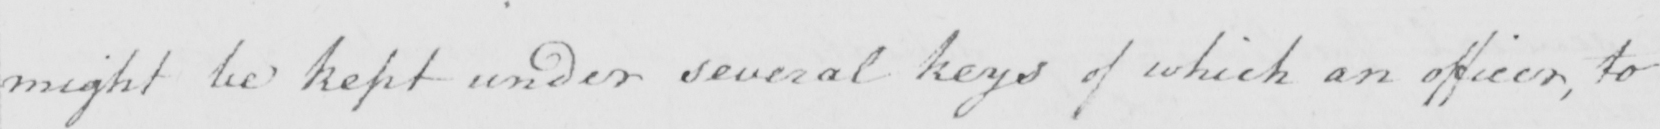What does this handwritten line say? might be kept under several keys of which an officer , to 